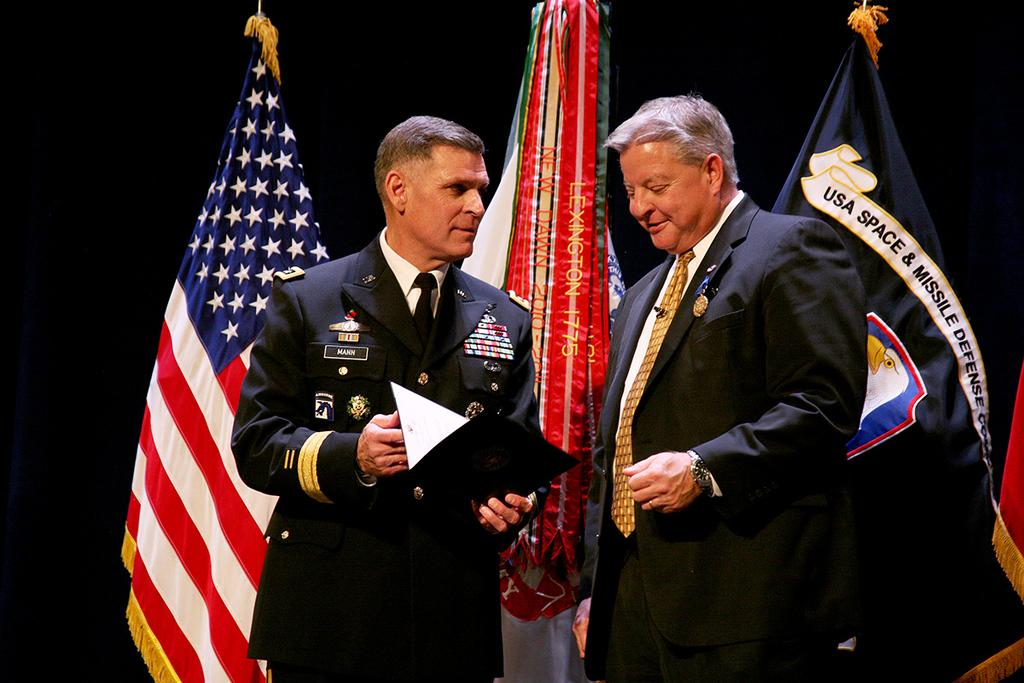How many people are in the image? There are two persons standing in the image. What are the expressions on their faces? The persons are smiling. What are the persons wearing? The persons are wearing suits. What are the persons holding in their hands? The persons are holding a book in their hands. What can be seen in the background of the image? There are flags visible in the background. How would you describe the lighting in the image? The background of the image is dark. What type of pipe can be seen in the image? There is no pipe present in the image. What list is the person holding in their hands? The persons are holding a book, not a list, in their hands. 